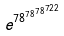<formula> <loc_0><loc_0><loc_500><loc_500>e ^ { 7 8 ^ { 7 8 ^ { 7 8 ^ { 7 2 2 } } } }</formula> 